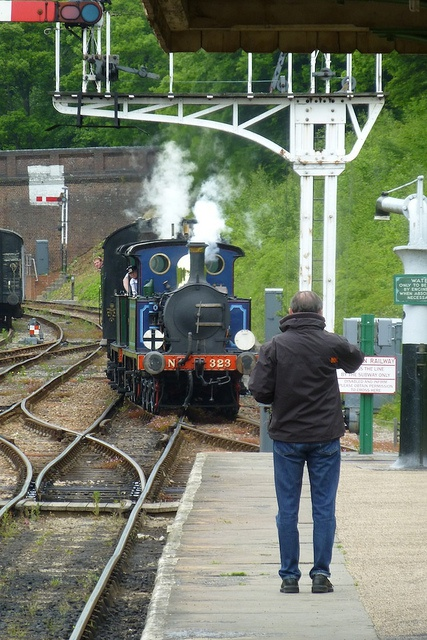Describe the objects in this image and their specific colors. I can see train in lightgray, black, gray, darkblue, and white tones, people in lightgray, black, navy, gray, and darkblue tones, train in lightgray, black, gray, purple, and darkblue tones, and people in lightgray, black, gray, darkgray, and lavender tones in this image. 